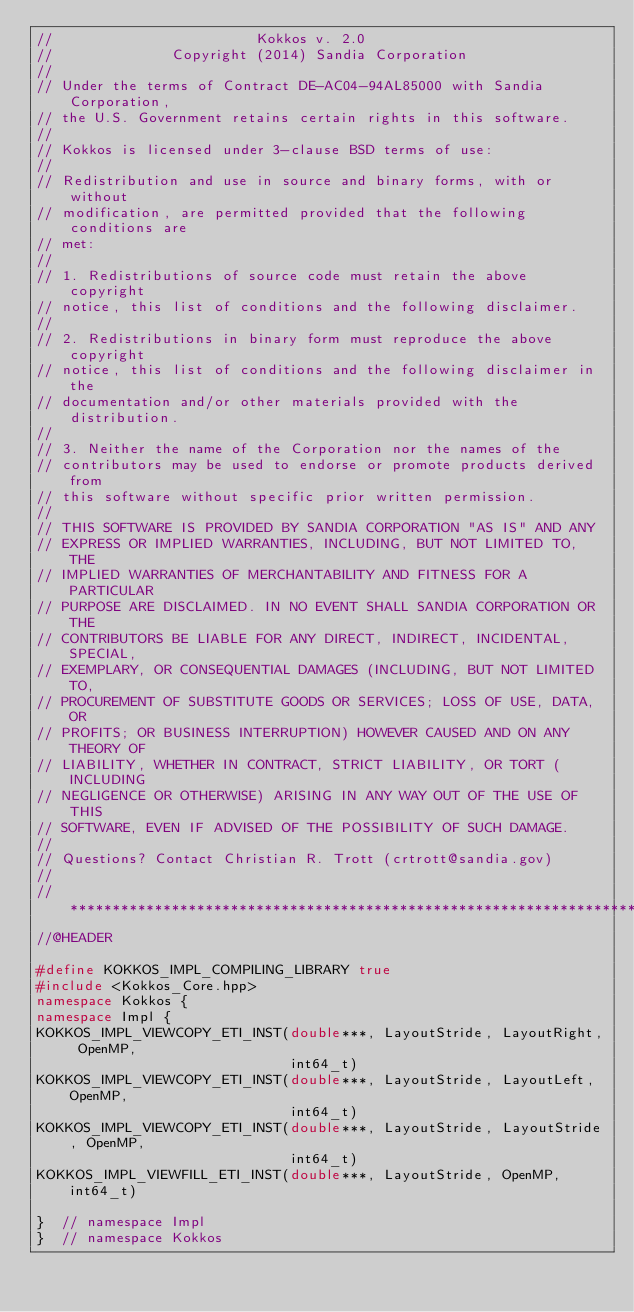Convert code to text. <code><loc_0><loc_0><loc_500><loc_500><_C++_>//                        Kokkos v. 2.0
//              Copyright (2014) Sandia Corporation
//
// Under the terms of Contract DE-AC04-94AL85000 with Sandia Corporation,
// the U.S. Government retains certain rights in this software.
//
// Kokkos is licensed under 3-clause BSD terms of use:
//
// Redistribution and use in source and binary forms, with or without
// modification, are permitted provided that the following conditions are
// met:
//
// 1. Redistributions of source code must retain the above copyright
// notice, this list of conditions and the following disclaimer.
//
// 2. Redistributions in binary form must reproduce the above copyright
// notice, this list of conditions and the following disclaimer in the
// documentation and/or other materials provided with the distribution.
//
// 3. Neither the name of the Corporation nor the names of the
// contributors may be used to endorse or promote products derived from
// this software without specific prior written permission.
//
// THIS SOFTWARE IS PROVIDED BY SANDIA CORPORATION "AS IS" AND ANY
// EXPRESS OR IMPLIED WARRANTIES, INCLUDING, BUT NOT LIMITED TO, THE
// IMPLIED WARRANTIES OF MERCHANTABILITY AND FITNESS FOR A PARTICULAR
// PURPOSE ARE DISCLAIMED. IN NO EVENT SHALL SANDIA CORPORATION OR THE
// CONTRIBUTORS BE LIABLE FOR ANY DIRECT, INDIRECT, INCIDENTAL, SPECIAL,
// EXEMPLARY, OR CONSEQUENTIAL DAMAGES (INCLUDING, BUT NOT LIMITED TO,
// PROCUREMENT OF SUBSTITUTE GOODS OR SERVICES; LOSS OF USE, DATA, OR
// PROFITS; OR BUSINESS INTERRUPTION) HOWEVER CAUSED AND ON ANY THEORY OF
// LIABILITY, WHETHER IN CONTRACT, STRICT LIABILITY, OR TORT (INCLUDING
// NEGLIGENCE OR OTHERWISE) ARISING IN ANY WAY OUT OF THE USE OF THIS
// SOFTWARE, EVEN IF ADVISED OF THE POSSIBILITY OF SUCH DAMAGE.
//
// Questions? Contact Christian R. Trott (crtrott@sandia.gov)
//
// ************************************************************************
//@HEADER

#define KOKKOS_IMPL_COMPILING_LIBRARY true
#include <Kokkos_Core.hpp>
namespace Kokkos {
namespace Impl {
KOKKOS_IMPL_VIEWCOPY_ETI_INST(double***, LayoutStride, LayoutRight, OpenMP,
                              int64_t)
KOKKOS_IMPL_VIEWCOPY_ETI_INST(double***, LayoutStride, LayoutLeft, OpenMP,
                              int64_t)
KOKKOS_IMPL_VIEWCOPY_ETI_INST(double***, LayoutStride, LayoutStride, OpenMP,
                              int64_t)
KOKKOS_IMPL_VIEWFILL_ETI_INST(double***, LayoutStride, OpenMP, int64_t)

}  // namespace Impl
}  // namespace Kokkos
</code> 